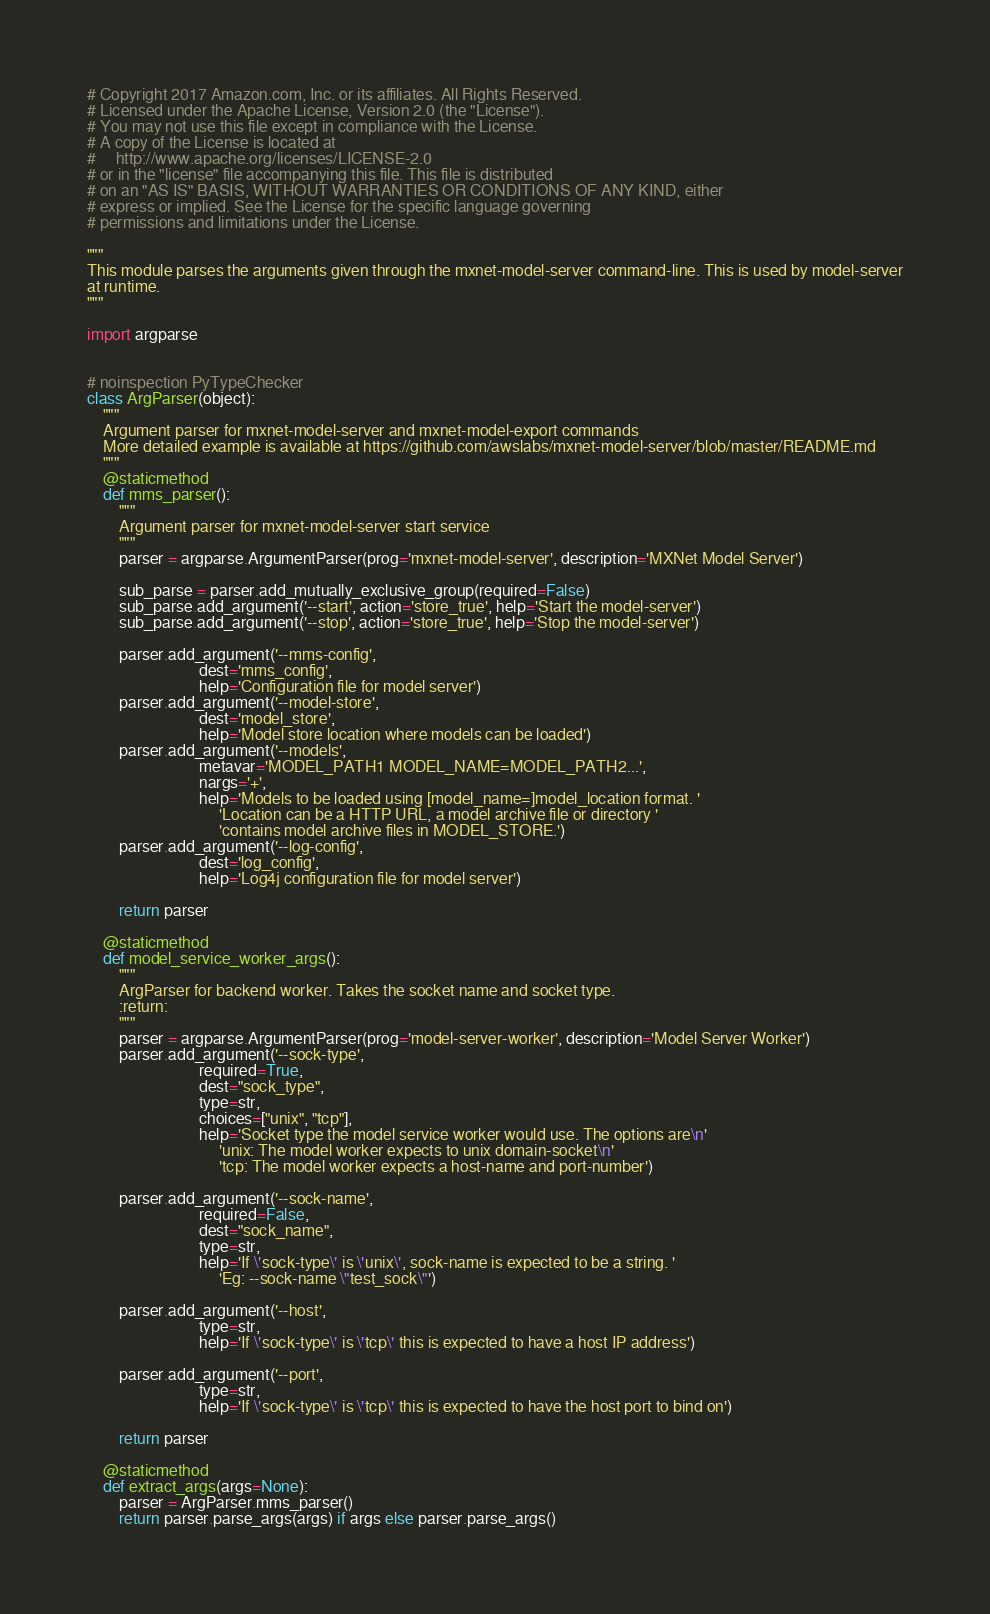<code> <loc_0><loc_0><loc_500><loc_500><_Python_># Copyright 2017 Amazon.com, Inc. or its affiliates. All Rights Reserved.
# Licensed under the Apache License, Version 2.0 (the "License").
# You may not use this file except in compliance with the License.
# A copy of the License is located at
#     http://www.apache.org/licenses/LICENSE-2.0
# or in the "license" file accompanying this file. This file is distributed
# on an "AS IS" BASIS, WITHOUT WARRANTIES OR CONDITIONS OF ANY KIND, either
# express or implied. See the License for the specific language governing
# permissions and limitations under the License.

"""
This module parses the arguments given through the mxnet-model-server command-line. This is used by model-server
at runtime.
"""

import argparse


# noinspection PyTypeChecker
class ArgParser(object):
    """
    Argument parser for mxnet-model-server and mxnet-model-export commands
    More detailed example is available at https://github.com/awslabs/mxnet-model-server/blob/master/README.md
    """
    @staticmethod
    def mms_parser():
        """
        Argument parser for mxnet-model-server start service
        """
        parser = argparse.ArgumentParser(prog='mxnet-model-server', description='MXNet Model Server')

        sub_parse = parser.add_mutually_exclusive_group(required=False)
        sub_parse.add_argument('--start', action='store_true', help='Start the model-server')
        sub_parse.add_argument('--stop', action='store_true', help='Stop the model-server')

        parser.add_argument('--mms-config',
                            dest='mms_config',
                            help='Configuration file for model server')
        parser.add_argument('--model-store',
                            dest='model_store',
                            help='Model store location where models can be loaded')
        parser.add_argument('--models',
                            metavar='MODEL_PATH1 MODEL_NAME=MODEL_PATH2...',
                            nargs='+',
                            help='Models to be loaded using [model_name=]model_location format. '
                                 'Location can be a HTTP URL, a model archive file or directory '
                                 'contains model archive files in MODEL_STORE.')
        parser.add_argument('--log-config',
                            dest='log_config',
                            help='Log4j configuration file for model server')

        return parser

    @staticmethod
    def model_service_worker_args():
        """
        ArgParser for backend worker. Takes the socket name and socket type.
        :return:
        """
        parser = argparse.ArgumentParser(prog='model-server-worker', description='Model Server Worker')
        parser.add_argument('--sock-type',
                            required=True,
                            dest="sock_type",
                            type=str,
                            choices=["unix", "tcp"],
                            help='Socket type the model service worker would use. The options are\n'
                                 'unix: The model worker expects to unix domain-socket\n'
                                 'tcp: The model worker expects a host-name and port-number')

        parser.add_argument('--sock-name',
                            required=False,
                            dest="sock_name",
                            type=str,
                            help='If \'sock-type\' is \'unix\', sock-name is expected to be a string. '
                                 'Eg: --sock-name \"test_sock\"')

        parser.add_argument('--host',
                            type=str,
                            help='If \'sock-type\' is \'tcp\' this is expected to have a host IP address')

        parser.add_argument('--port',
                            type=str,
                            help='If \'sock-type\' is \'tcp\' this is expected to have the host port to bind on')

        return parser

    @staticmethod
    def extract_args(args=None):
        parser = ArgParser.mms_parser()
        return parser.parse_args(args) if args else parser.parse_args()
</code> 